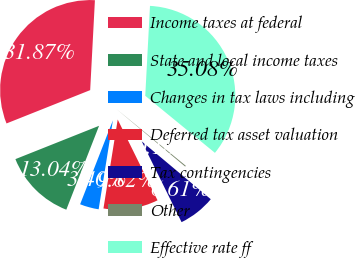Convert chart to OTSL. <chart><loc_0><loc_0><loc_500><loc_500><pie_chart><fcel>Income taxes at federal<fcel>State and local income taxes<fcel>Changes in tax laws including<fcel>Deferred tax asset valuation<fcel>Tax contingencies<fcel>Other<fcel>Effective rate ff<nl><fcel>31.87%<fcel>13.04%<fcel>3.4%<fcel>9.82%<fcel>6.61%<fcel>0.18%<fcel>35.08%<nl></chart> 